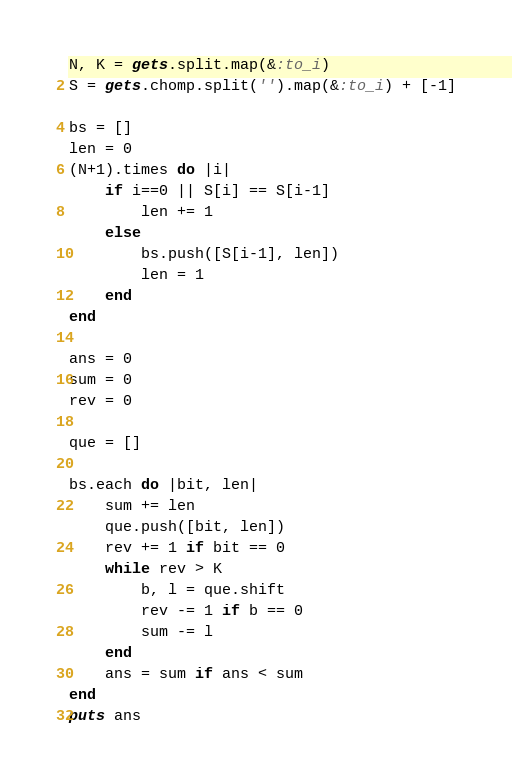Convert code to text. <code><loc_0><loc_0><loc_500><loc_500><_Ruby_>N, K = gets.split.map(&:to_i)
S = gets.chomp.split('').map(&:to_i) + [-1]

bs = []
len = 0
(N+1).times do |i|
    if i==0 || S[i] == S[i-1]
        len += 1
    else
        bs.push([S[i-1], len])
        len = 1
    end
end

ans = 0
sum = 0
rev = 0

que = []

bs.each do |bit, len|
    sum += len
    que.push([bit, len])
    rev += 1 if bit == 0
    while rev > K
        b, l = que.shift
        rev -= 1 if b == 0
        sum -= l
    end
    ans = sum if ans < sum
end
puts ans</code> 